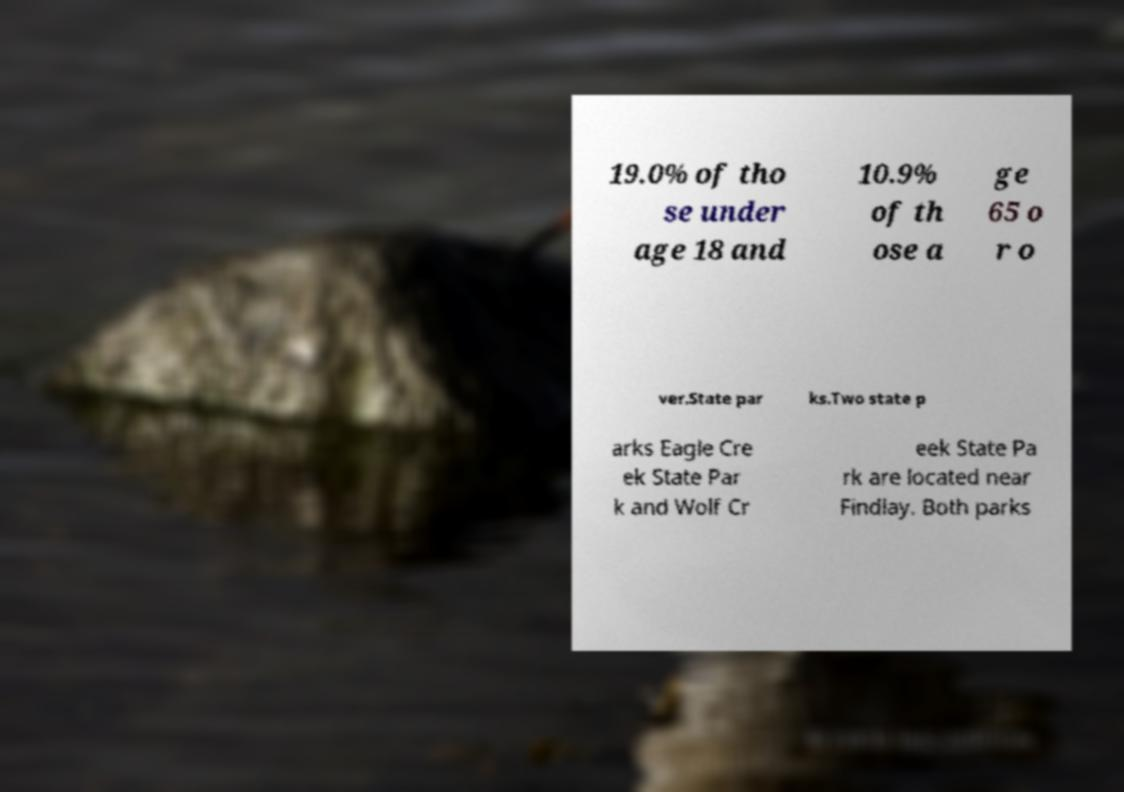Please identify and transcribe the text found in this image. 19.0% of tho se under age 18 and 10.9% of th ose a ge 65 o r o ver.State par ks.Two state p arks Eagle Cre ek State Par k and Wolf Cr eek State Pa rk are located near Findlay. Both parks 